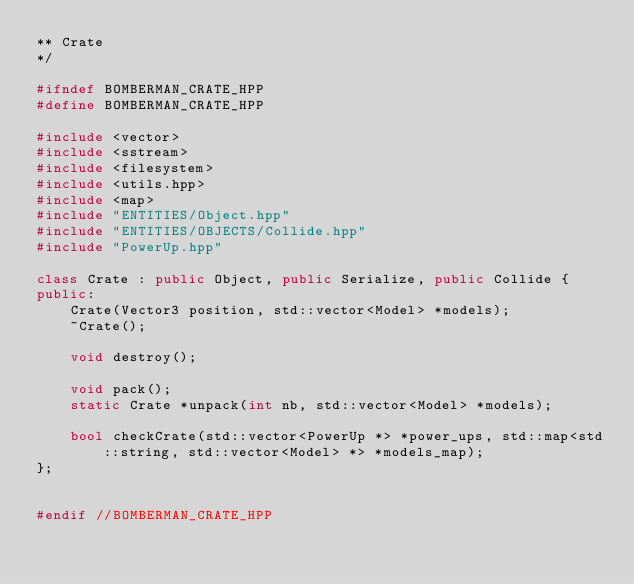<code> <loc_0><loc_0><loc_500><loc_500><_C++_>** Crate
*/

#ifndef BOMBERMAN_CRATE_HPP
#define BOMBERMAN_CRATE_HPP

#include <vector>
#include <sstream>
#include <filesystem>
#include <utils.hpp>
#include <map>
#include "ENTITIES/Object.hpp"
#include "ENTITIES/OBJECTS/Collide.hpp"
#include "PowerUp.hpp"

class Crate : public Object, public Serialize, public Collide {
public:
    Crate(Vector3 position, std::vector<Model> *models);
    ~Crate();

    void destroy();

    void pack();
    static Crate *unpack(int nb, std::vector<Model> *models);

    bool checkCrate(std::vector<PowerUp *> *power_ups, std::map<std::string, std::vector<Model> *> *models_map);
};


#endif //BOMBERMAN_CRATE_HPP
</code> 